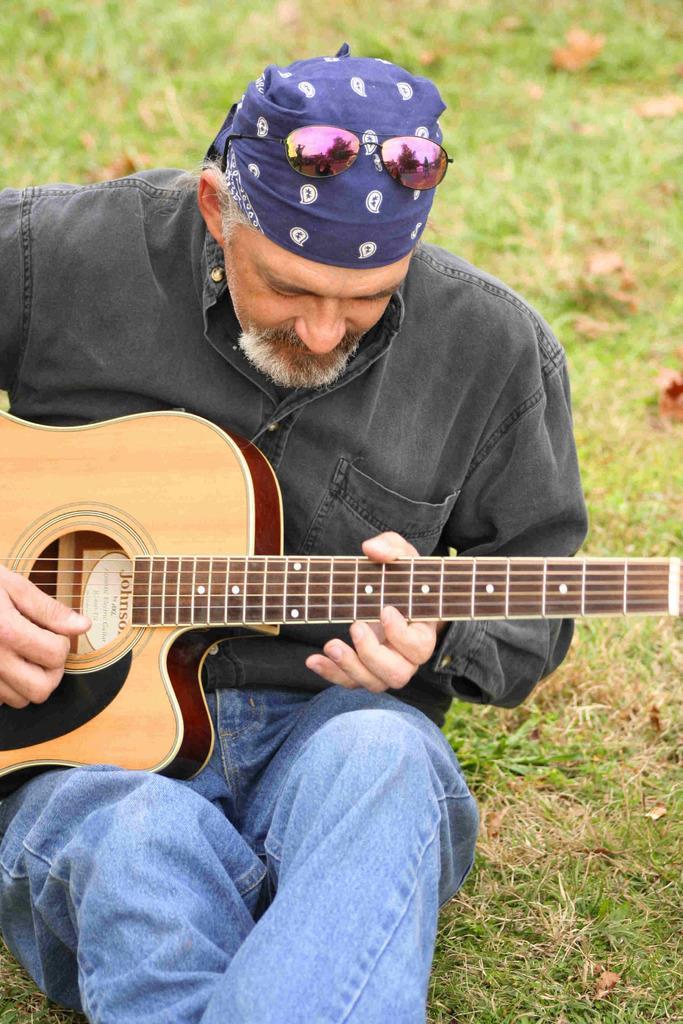Could you give a brief overview of what you see in this image? In the image there is a man who wore goggles on his head holding a guitar and playing it. In background there is a grass. 